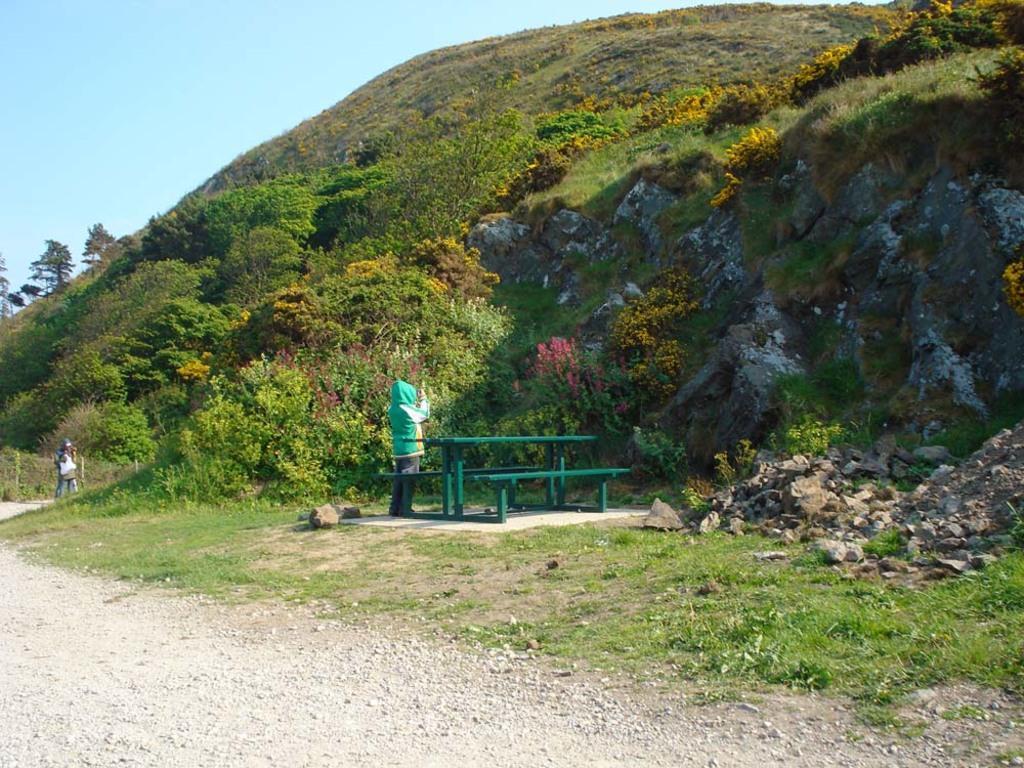Could you give a brief overview of what you see in this image? In this image in the background there are some mountains and trees, and in the center there is one person who is standing and beside him there is one bench. On the left side there is another man who is standing, at the bottom there is a walkway and some grass. On the top of the image there is sky. 